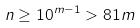<formula> <loc_0><loc_0><loc_500><loc_500>n \geq 1 0 ^ { m - 1 } > 8 1 m</formula> 